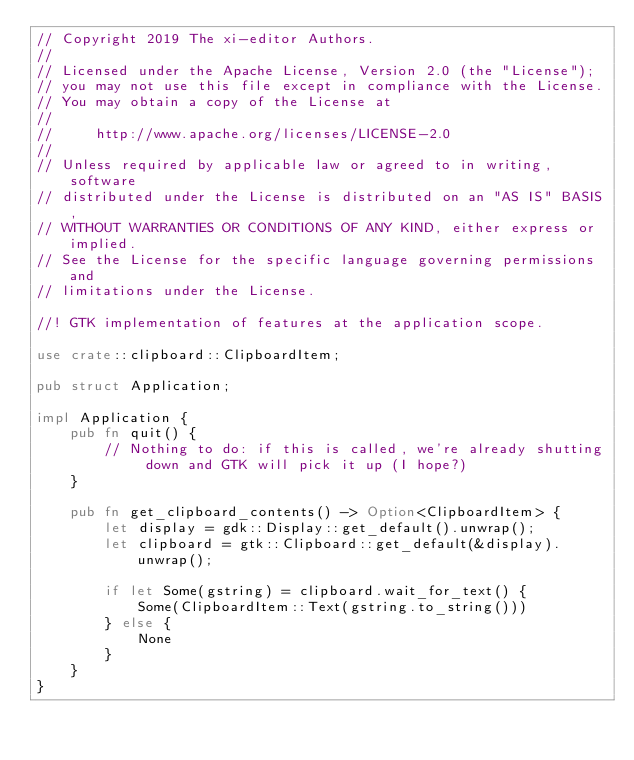<code> <loc_0><loc_0><loc_500><loc_500><_Rust_>// Copyright 2019 The xi-editor Authors.
//
// Licensed under the Apache License, Version 2.0 (the "License");
// you may not use this file except in compliance with the License.
// You may obtain a copy of the License at
//
//     http://www.apache.org/licenses/LICENSE-2.0
//
// Unless required by applicable law or agreed to in writing, software
// distributed under the License is distributed on an "AS IS" BASIS,
// WITHOUT WARRANTIES OR CONDITIONS OF ANY KIND, either express or implied.
// See the License for the specific language governing permissions and
// limitations under the License.

//! GTK implementation of features at the application scope.

use crate::clipboard::ClipboardItem;

pub struct Application;

impl Application {
    pub fn quit() {
        // Nothing to do: if this is called, we're already shutting down and GTK will pick it up (I hope?)
    }

    pub fn get_clipboard_contents() -> Option<ClipboardItem> {
        let display = gdk::Display::get_default().unwrap();
        let clipboard = gtk::Clipboard::get_default(&display).unwrap();

        if let Some(gstring) = clipboard.wait_for_text() {
            Some(ClipboardItem::Text(gstring.to_string()))
        } else {
            None
        }
    }
}
</code> 